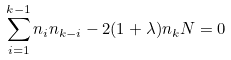<formula> <loc_0><loc_0><loc_500><loc_500>\sum _ { i = 1 } ^ { k - 1 } n _ { i } n _ { k - i } - 2 ( 1 + \lambda ) n _ { k } N = 0</formula> 